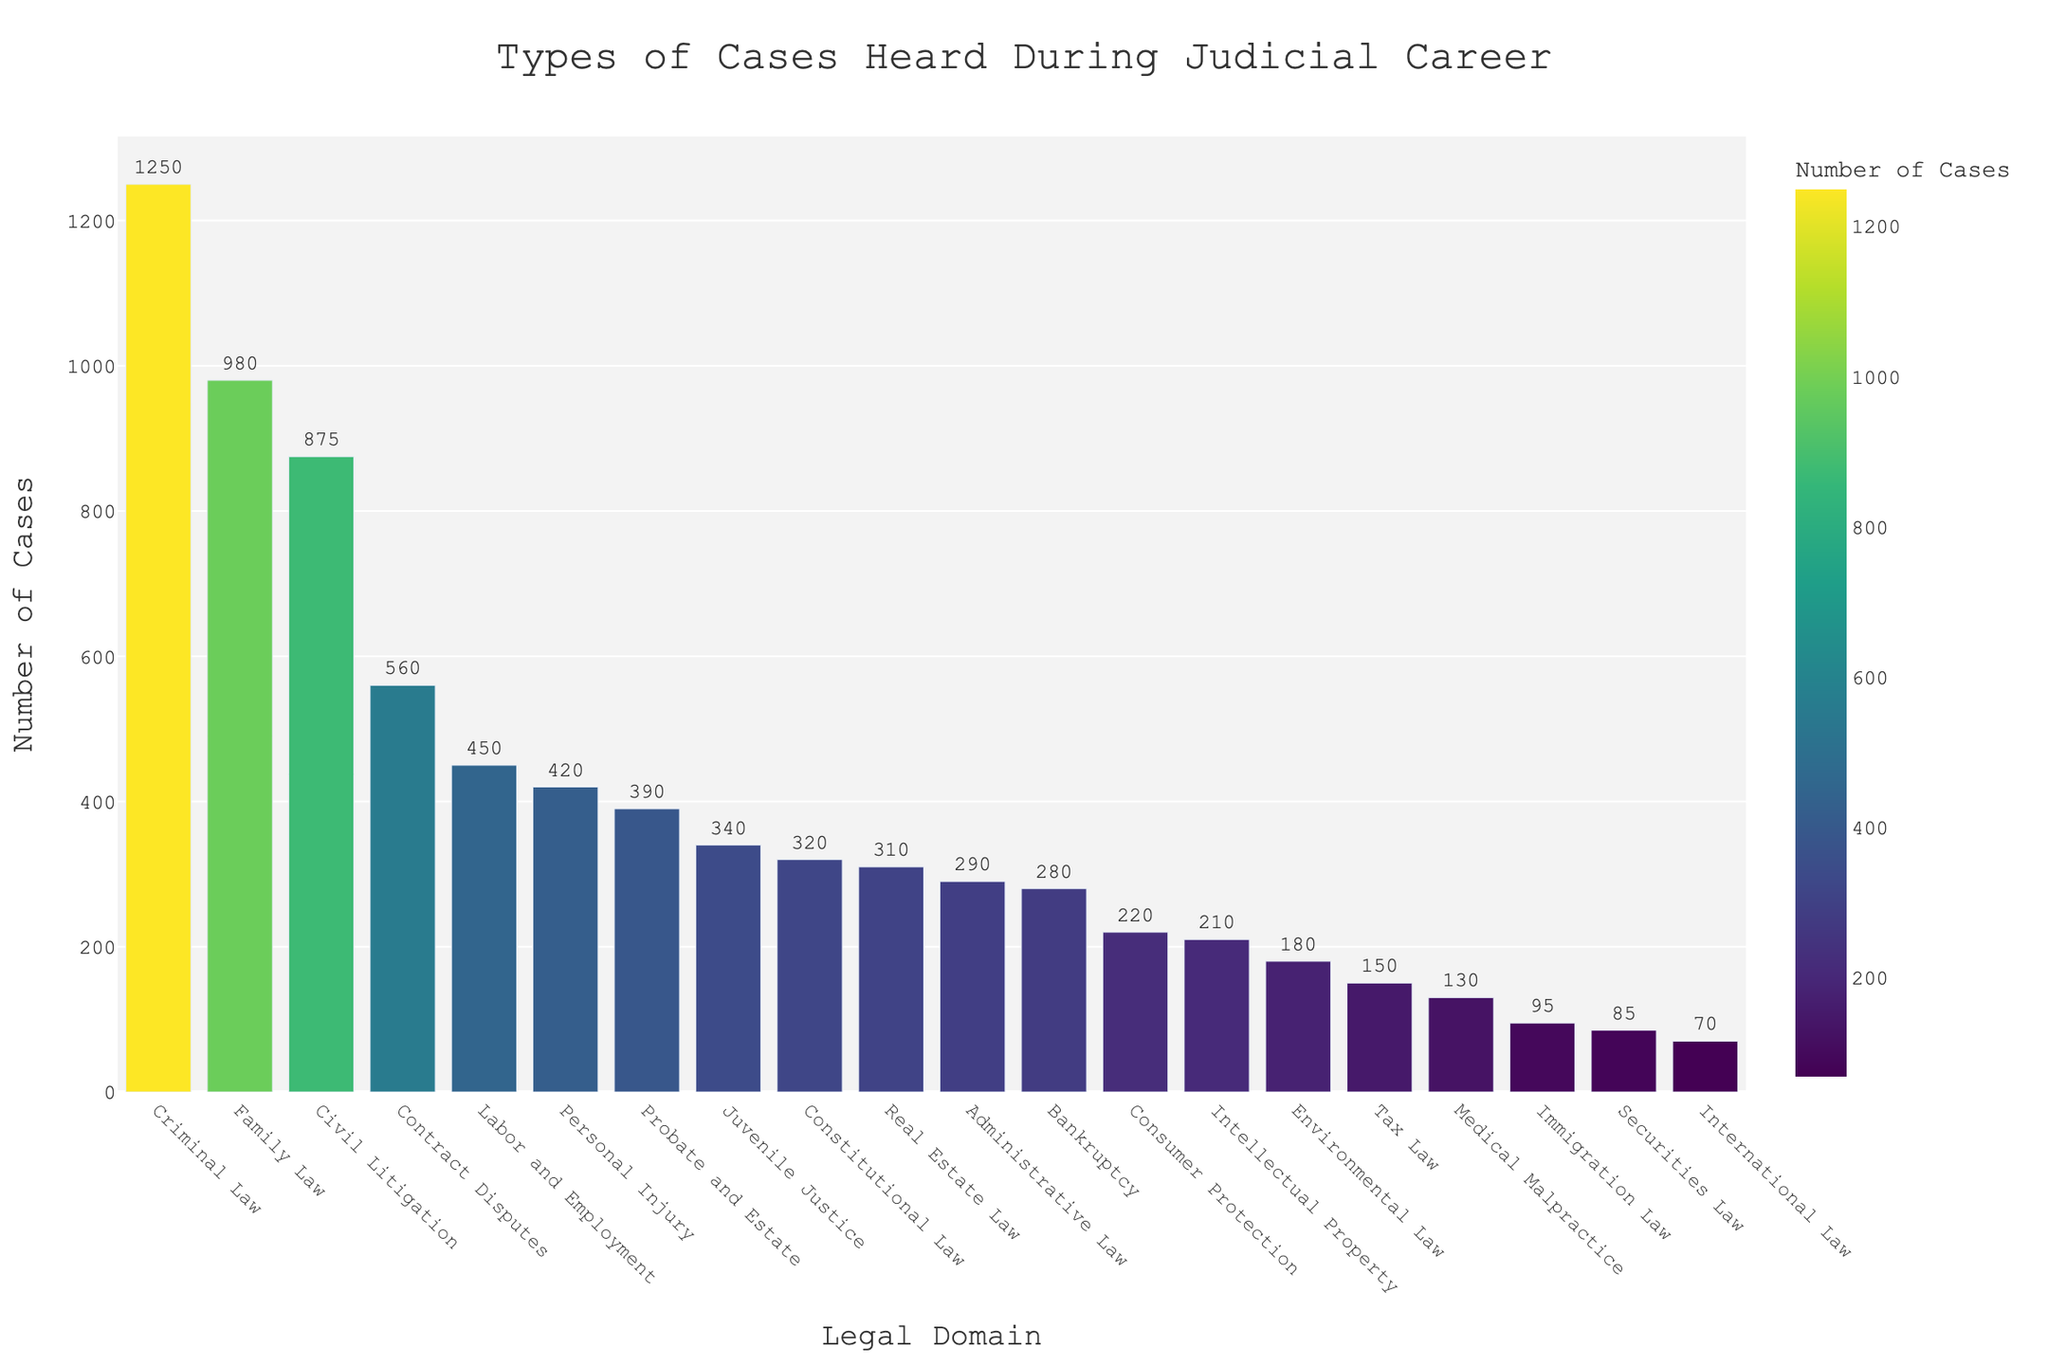What is the total number of cases heard in Criminal Law and Family Law combined? First, identify the number of cases for Criminal Law (1250) and Family Law (980) from the chart. Then, add these two values: 1250 + 980 = 2230.
Answer: 2230 Which legal domain has the fewest number of cases? By inspecting the chart, identify the shortest bar, which corresponds to International Law with 70 cases.
Answer: International Law How many more cases were heard in Civil Litigation compared to Environmental Law? Identify the number of cases for Civil Litigation (875) and Environmental Law (180). Subtract the smaller number from the larger number: 875 - 180 = 695.
Answer: 695 Which three legal domains have a similar number of cases heard, and what are these numbers? Look for bars that have similar heights. Probate and Estate (390), Administrative Law (290), and Immigration Law (95) are distinct. However, Personal Injury (420) and Contract Disputes (560) are visually closer. Family Law (980), Civil Litigation (875), and Contract Disputes (560) are comparatively similar.
Answer: Family Law, Civil Litigation, Contract Disputes Between Bankruptcy and Tax Law, which has more cases, and by how much? Identify the number of cases for Bankruptcy (280) and Tax Law (150). Subtract the smaller number from the larger number: 280 - 150 = 130.
Answer: Bankruptcy, 130 more Rank the top three legal domains by the number of cases heard. Identify the bars with the highest values and rank them. The top three are Criminal Law (1250), Family Law (980), and Civil Litigation (875).
Answer: Criminal Law, Family Law, Civil Litigation What is the difference in the number of cases between the domains with the highest and lowest case counts? Identify the number of cases for the highest (Criminal Law, 1250) and the lowest (International Law, 70) case counts. Subtract the smaller number from the larger number: 1250 - 70 = 1180.
Answer: 1180 What is the median number of cases for the legal domains? List the number of cases in ascending order: 70, 85, 95, 130, 150, 180, 210, 220, 280, 290, 310, 320, 340, 390, 420, 450, 560, 875, 980, 1250. The median is the middle value of this list, which is between the 10th and 11th values: (290 + 310) / 2 = 300.
Answer: 300 